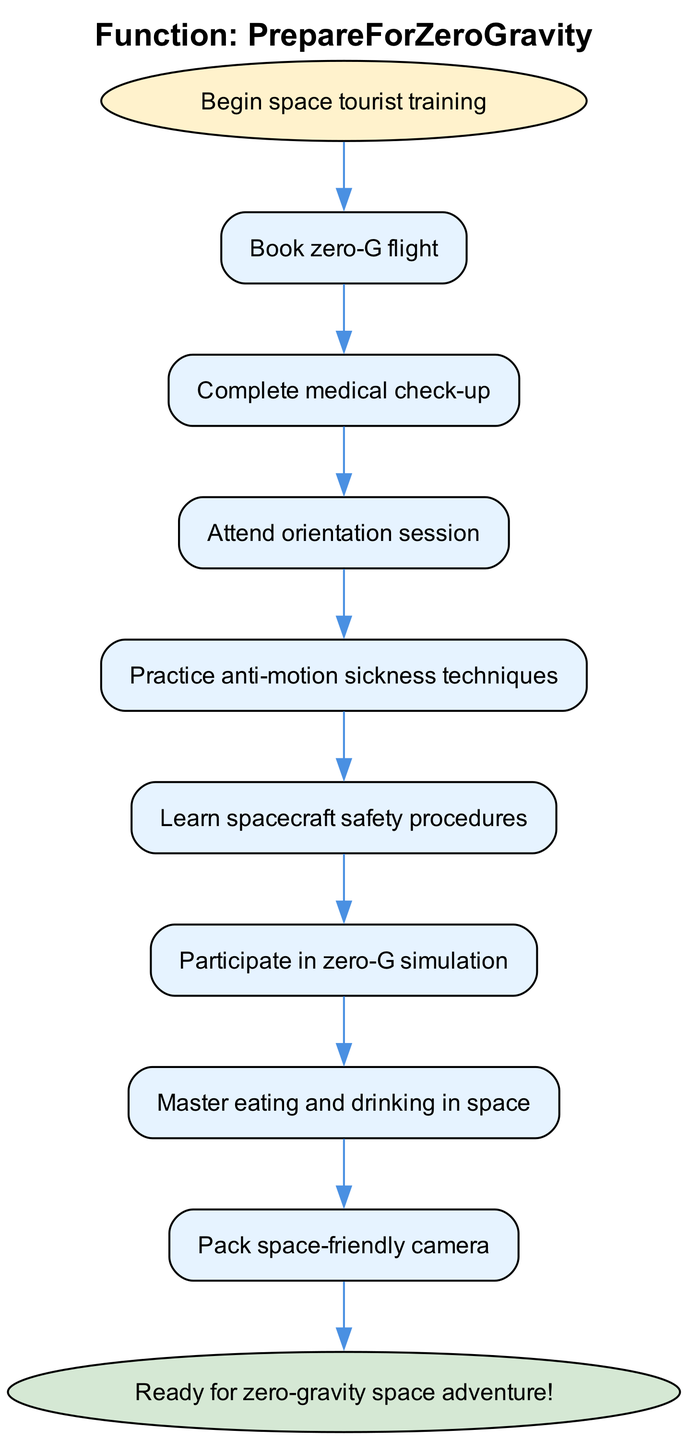What is the first step in the process? The first step in the flowchart, as indicated at the beginning, is "Begin space tourist training." This is the starting point from where all other steps follow.
Answer: Begin space tourist training How many steps are involved in preparing for zero-gravity? By counting the steps listed between the starting point and the end, we find there are a total of eight steps. Each step is connected sequentially, leading toward the final goal.
Answer: Eight steps What follows after completing the medical check-up? The step immediately after "Complete medical check-up" is "Attend orientation session." This shows the progression from one task to the next in preparing for zero-gravity.
Answer: Attend orientation session What is the last step before being ready for the zero-gravity adventure? The final step before reaching the endpoint is "Prepare for solar eclipse viewing." This step leads directly into the conclusion of being ready for the adventure.
Answer: Prepare for solar eclipse viewing Which step includes techniques related to motion sickness? The step that includes techniques on motion sickness is "Practice anti-motion sickness techniques." This indicates that the process addresses potential difficulties in zero-gravity conditions early on.
Answer: Practice anti-motion sickness techniques What is the relationship between "Learn spacecraft safety procedures" and "Participate in zero-G simulation"? "Learn spacecraft safety procedures" is a prerequisite for "Participate in zero-G simulation." It indicates that understanding safety is important before simulation practice can occur.
Answer: Prerequisite relationship What preparation is advised after mastering eating and drinking in space? After "Master eating and drinking in space," the next recommended action is to "Pack space-friendly camera." This shows that practical considerations come after mastering the essentials.
Answer: Pack space-friendly camera What function is this flowchart illustrating? The function illustrated in this flowchart is "PrepareForZeroGravity." This gives the overall purpose of the steps outlined in the diagram.
Answer: PrepareForZeroGravity 